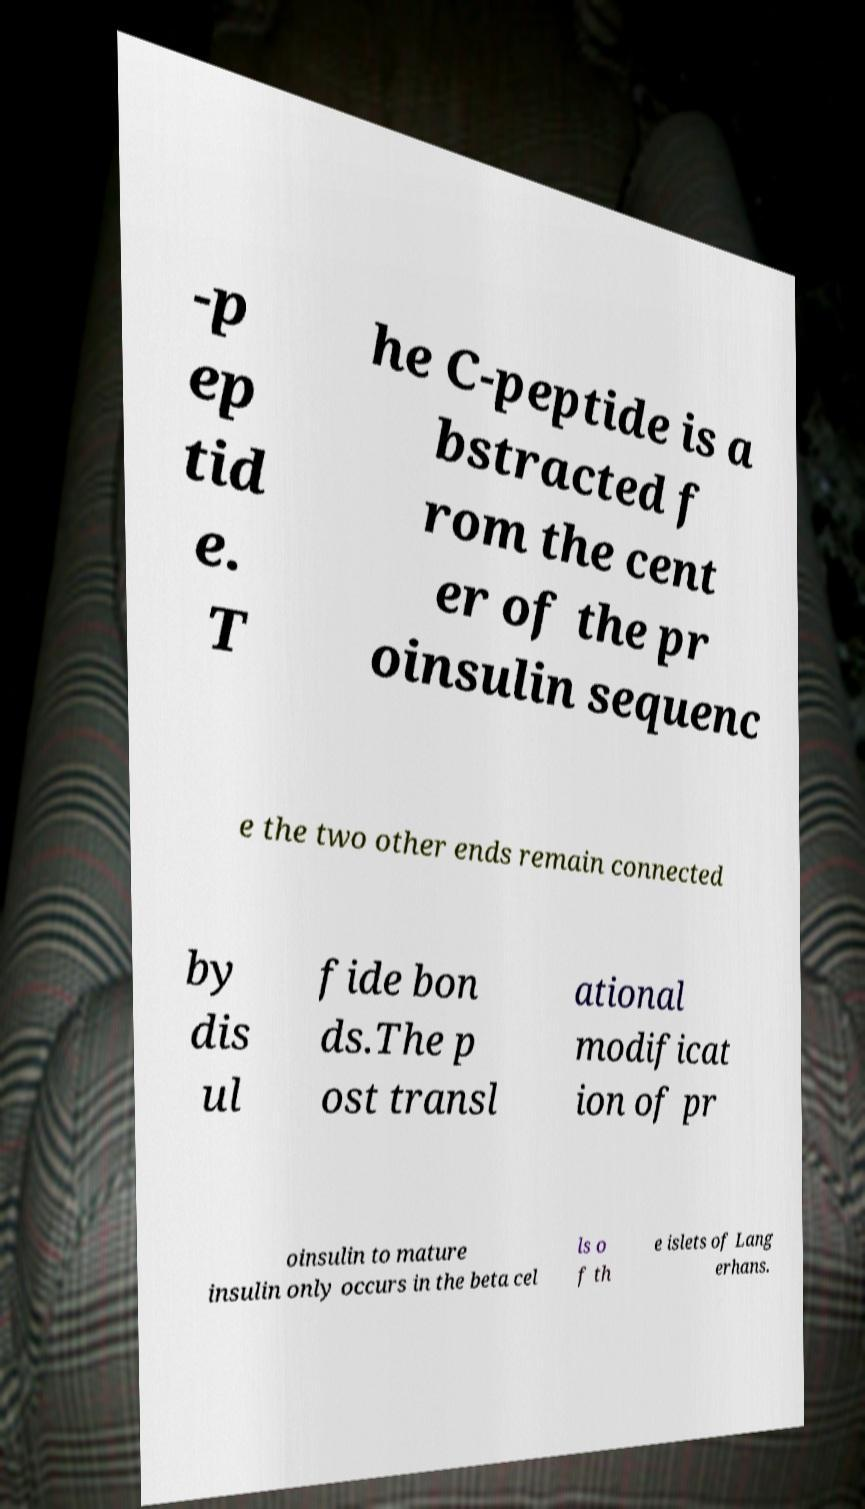For documentation purposes, I need the text within this image transcribed. Could you provide that? -p ep tid e. T he C-peptide is a bstracted f rom the cent er of the pr oinsulin sequenc e the two other ends remain connected by dis ul fide bon ds.The p ost transl ational modificat ion of pr oinsulin to mature insulin only occurs in the beta cel ls o f th e islets of Lang erhans. 